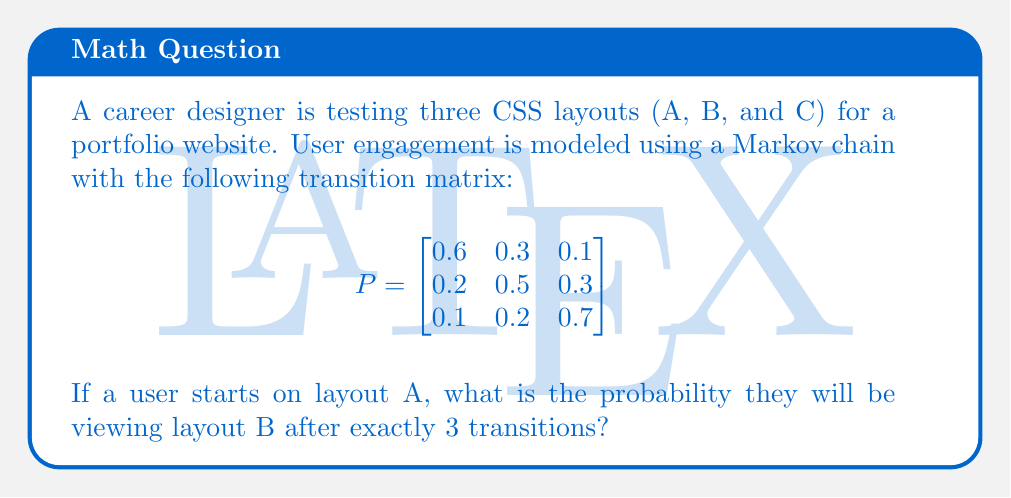Help me with this question. To solve this problem, we need to use the Chapman-Kolmogorov equations and calculate $P^3$. This will give us the probability of transitioning from any state to any other state in exactly 3 steps.

Step 1: Calculate $P^2$
$$P^2 = P \times P = \begin{bmatrix}
0.6 & 0.3 & 0.1 \\
0.2 & 0.5 & 0.3 \\
0.1 & 0.2 & 0.7
\end{bmatrix} \times \begin{bmatrix}
0.6 & 0.3 & 0.1 \\
0.2 & 0.5 & 0.3 \\
0.1 & 0.2 & 0.7
\end{bmatrix}$$

$$P^2 = \begin{bmatrix}
0.42 & 0.36 & 0.22 \\
0.29 & 0.40 & 0.31 \\
0.19 & 0.29 & 0.52
\end{bmatrix}$$

Step 2: Calculate $P^3$
$$P^3 = P^2 \times P = \begin{bmatrix}
0.42 & 0.36 & 0.22 \\
0.29 & 0.40 & 0.31 \\
0.19 & 0.29 & 0.52
\end{bmatrix} \times \begin{bmatrix}
0.6 & 0.3 & 0.1 \\
0.2 & 0.5 & 0.3 \\
0.1 & 0.2 & 0.7
\end{bmatrix}$$

$$P^3 = \begin{bmatrix}
0.338 & 0.360 & 0.302 \\
0.308 & 0.366 & 0.326 \\
0.233 & 0.331 & 0.436
\end{bmatrix}$$

Step 3: Identify the probability of transitioning from A to B in 3 steps
The probability of transitioning from A to B in 3 steps is the element in the first row, second column of $P^3$, which is 0.360.
Answer: 0.360 